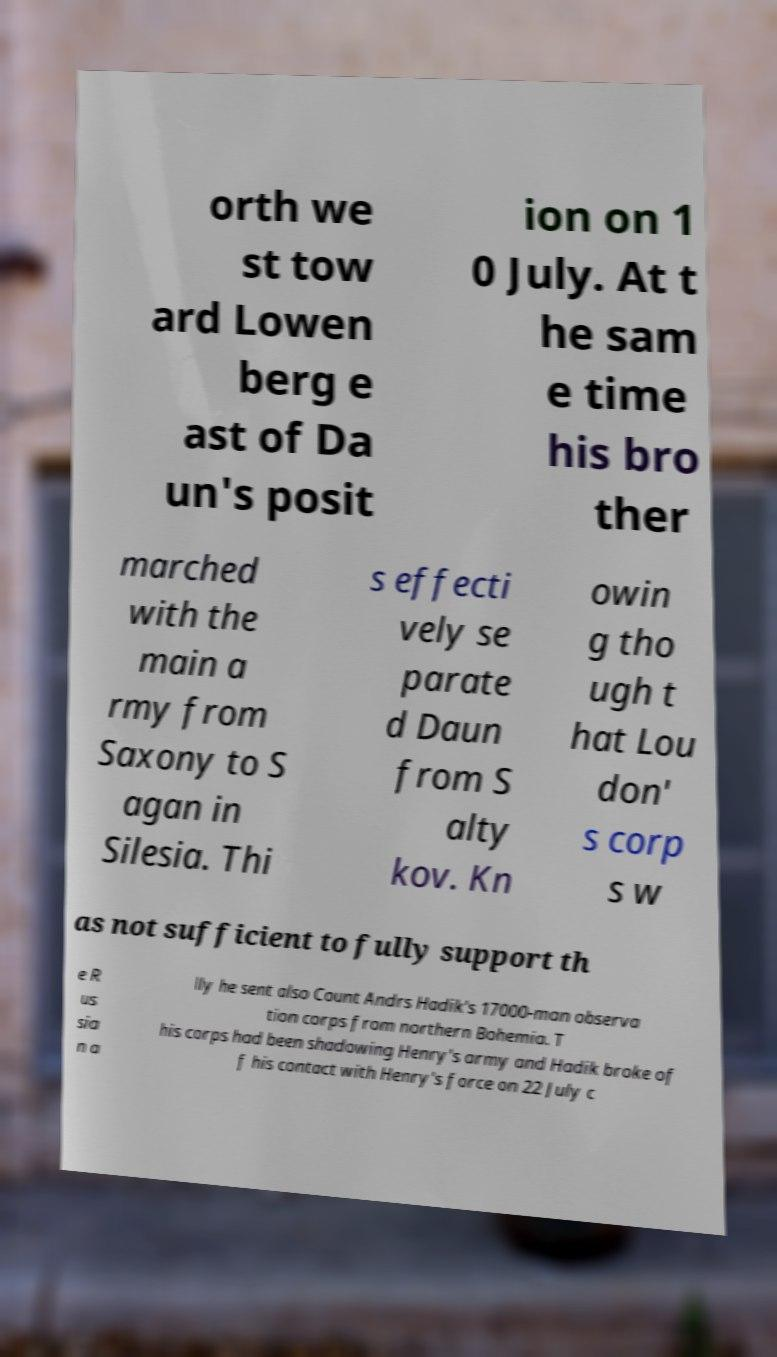Can you accurately transcribe the text from the provided image for me? orth we st tow ard Lowen berg e ast of Da un's posit ion on 1 0 July. At t he sam e time his bro ther marched with the main a rmy from Saxony to S agan in Silesia. Thi s effecti vely se parate d Daun from S alty kov. Kn owin g tho ugh t hat Lou don' s corp s w as not sufficient to fully support th e R us sia n a lly he sent also Count Andrs Hadik's 17000-man observa tion corps from northern Bohemia. T his corps had been shadowing Henry's army and Hadik broke of f his contact with Henry's force on 22 July c 